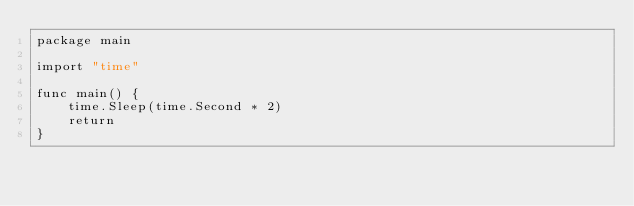Convert code to text. <code><loc_0><loc_0><loc_500><loc_500><_Go_>package main

import "time"

func main() {
	time.Sleep(time.Second * 2)
	return
}

</code> 